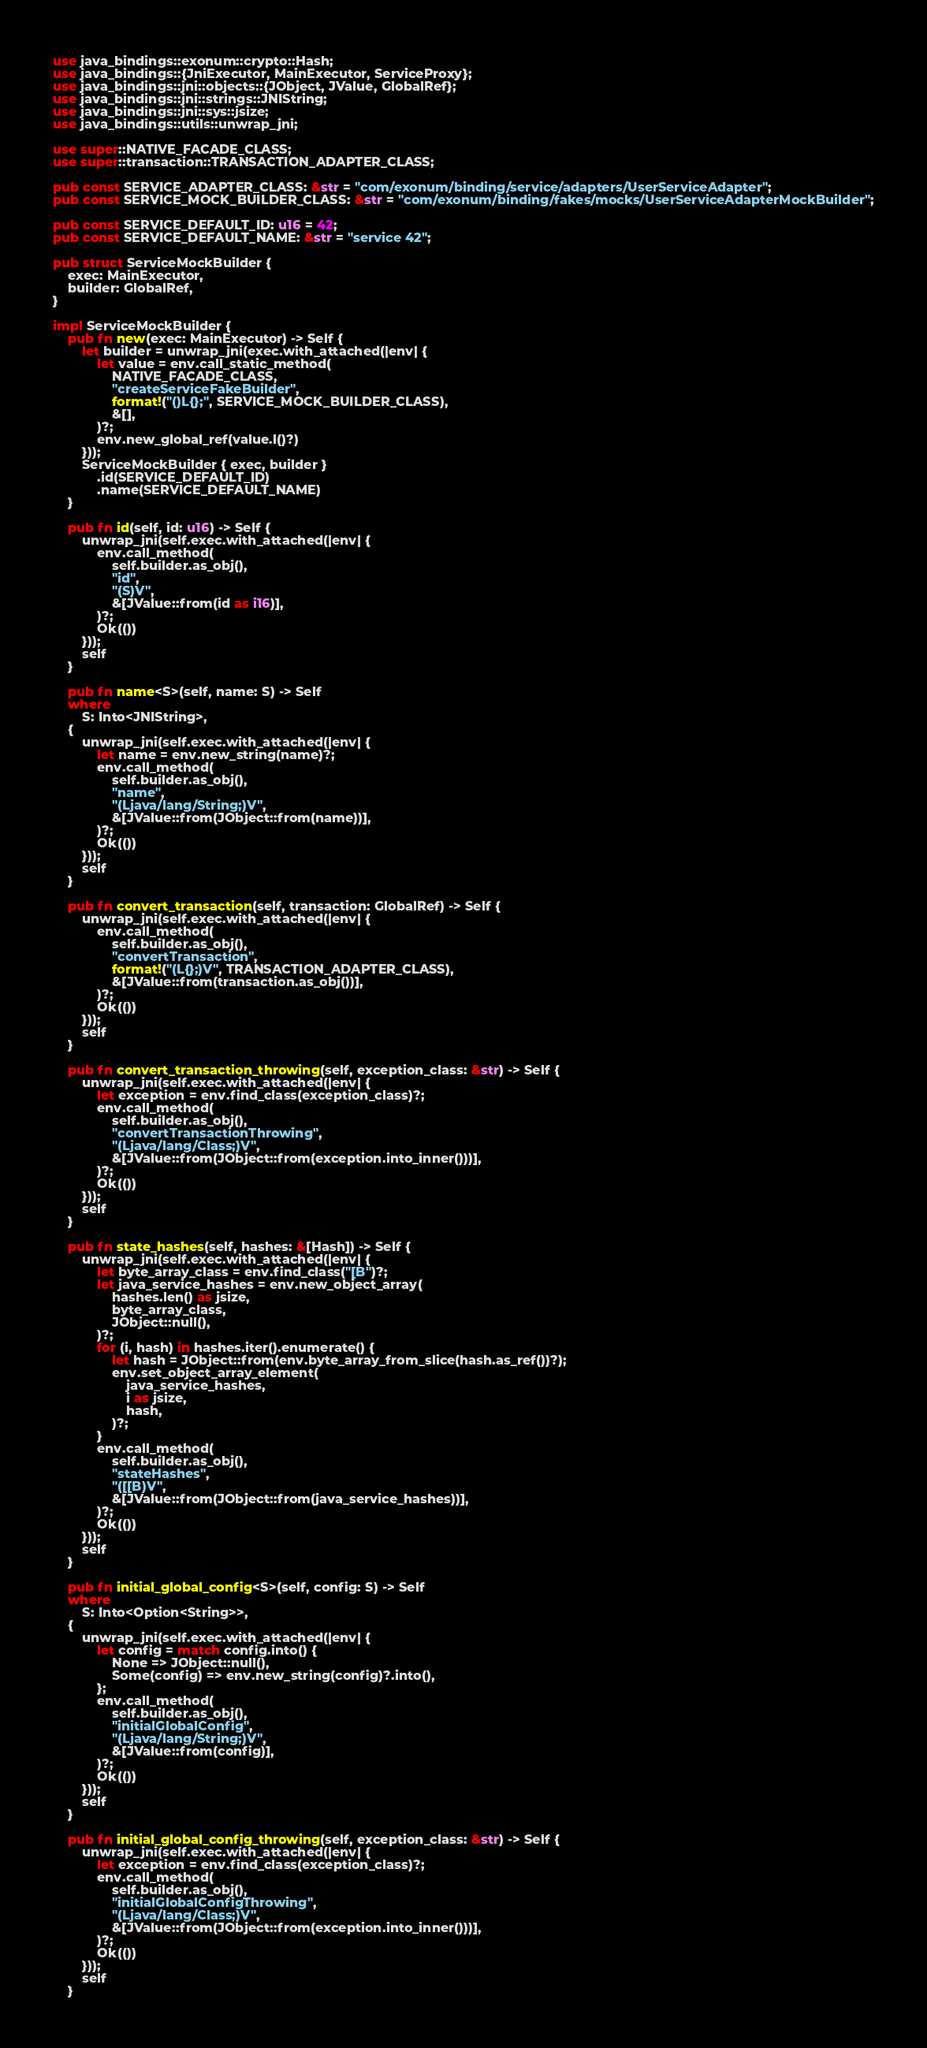Convert code to text. <code><loc_0><loc_0><loc_500><loc_500><_Rust_>use java_bindings::exonum::crypto::Hash;
use java_bindings::{JniExecutor, MainExecutor, ServiceProxy};
use java_bindings::jni::objects::{JObject, JValue, GlobalRef};
use java_bindings::jni::strings::JNIString;
use java_bindings::jni::sys::jsize;
use java_bindings::utils::unwrap_jni;

use super::NATIVE_FACADE_CLASS;
use super::transaction::TRANSACTION_ADAPTER_CLASS;

pub const SERVICE_ADAPTER_CLASS: &str = "com/exonum/binding/service/adapters/UserServiceAdapter";
pub const SERVICE_MOCK_BUILDER_CLASS: &str = "com/exonum/binding/fakes/mocks/UserServiceAdapterMockBuilder";

pub const SERVICE_DEFAULT_ID: u16 = 42;
pub const SERVICE_DEFAULT_NAME: &str = "service 42";

pub struct ServiceMockBuilder {
    exec: MainExecutor,
    builder: GlobalRef,
}

impl ServiceMockBuilder {
    pub fn new(exec: MainExecutor) -> Self {
        let builder = unwrap_jni(exec.with_attached(|env| {
            let value = env.call_static_method(
                NATIVE_FACADE_CLASS,
                "createServiceFakeBuilder",
                format!("()L{};", SERVICE_MOCK_BUILDER_CLASS),
                &[],
            )?;
            env.new_global_ref(value.l()?)
        }));
        ServiceMockBuilder { exec, builder }
            .id(SERVICE_DEFAULT_ID)
            .name(SERVICE_DEFAULT_NAME)
    }

    pub fn id(self, id: u16) -> Self {
        unwrap_jni(self.exec.with_attached(|env| {
            env.call_method(
                self.builder.as_obj(),
                "id",
                "(S)V",
                &[JValue::from(id as i16)],
            )?;
            Ok(())
        }));
        self
    }

    pub fn name<S>(self, name: S) -> Self
    where
        S: Into<JNIString>,
    {
        unwrap_jni(self.exec.with_attached(|env| {
            let name = env.new_string(name)?;
            env.call_method(
                self.builder.as_obj(),
                "name",
                "(Ljava/lang/String;)V",
                &[JValue::from(JObject::from(name))],
            )?;
            Ok(())
        }));
        self
    }

    pub fn convert_transaction(self, transaction: GlobalRef) -> Self {
        unwrap_jni(self.exec.with_attached(|env| {
            env.call_method(
                self.builder.as_obj(),
                "convertTransaction",
                format!("(L{};)V", TRANSACTION_ADAPTER_CLASS),
                &[JValue::from(transaction.as_obj())],
            )?;
            Ok(())
        }));
        self
    }

    pub fn convert_transaction_throwing(self, exception_class: &str) -> Self {
        unwrap_jni(self.exec.with_attached(|env| {
            let exception = env.find_class(exception_class)?;
            env.call_method(
                self.builder.as_obj(),
                "convertTransactionThrowing",
                "(Ljava/lang/Class;)V",
                &[JValue::from(JObject::from(exception.into_inner()))],
            )?;
            Ok(())
        }));
        self
    }

    pub fn state_hashes(self, hashes: &[Hash]) -> Self {
        unwrap_jni(self.exec.with_attached(|env| {
            let byte_array_class = env.find_class("[B")?;
            let java_service_hashes = env.new_object_array(
                hashes.len() as jsize,
                byte_array_class,
                JObject::null(),
            )?;
            for (i, hash) in hashes.iter().enumerate() {
                let hash = JObject::from(env.byte_array_from_slice(hash.as_ref())?);
                env.set_object_array_element(
                    java_service_hashes,
                    i as jsize,
                    hash,
                )?;
            }
            env.call_method(
                self.builder.as_obj(),
                "stateHashes",
                "([[B)V",
                &[JValue::from(JObject::from(java_service_hashes))],
            )?;
            Ok(())
        }));
        self
    }

    pub fn initial_global_config<S>(self, config: S) -> Self
    where
        S: Into<Option<String>>,
    {
        unwrap_jni(self.exec.with_attached(|env| {
            let config = match config.into() {
                None => JObject::null(),
                Some(config) => env.new_string(config)?.into(),
            };
            env.call_method(
                self.builder.as_obj(),
                "initialGlobalConfig",
                "(Ljava/lang/String;)V",
                &[JValue::from(config)],
            )?;
            Ok(())
        }));
        self
    }

    pub fn initial_global_config_throwing(self, exception_class: &str) -> Self {
        unwrap_jni(self.exec.with_attached(|env| {
            let exception = env.find_class(exception_class)?;
            env.call_method(
                self.builder.as_obj(),
                "initialGlobalConfigThrowing",
                "(Ljava/lang/Class;)V",
                &[JValue::from(JObject::from(exception.into_inner()))],
            )?;
            Ok(())
        }));
        self
    }
</code> 